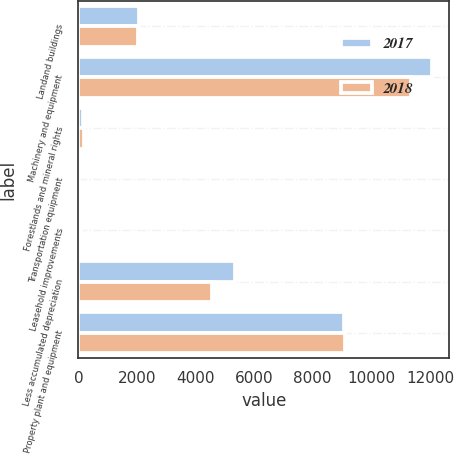Convert chart to OTSL. <chart><loc_0><loc_0><loc_500><loc_500><stacked_bar_chart><ecel><fcel>Landand buildings<fcel>Machinery and equipment<fcel>Forestlands and mineral rights<fcel>Transportation equipment<fcel>Leasehold improvements<fcel>Less accumulated depreciation<fcel>Property plant and equipment<nl><fcel>2017<fcel>2078.9<fcel>12064<fcel>158<fcel>30.1<fcel>88.9<fcel>5337.4<fcel>9082.5<nl><fcel>2018<fcel>2034.3<fcel>11349.7<fcel>208.3<fcel>30.7<fcel>59.5<fcel>4564.2<fcel>9118.3<nl></chart> 